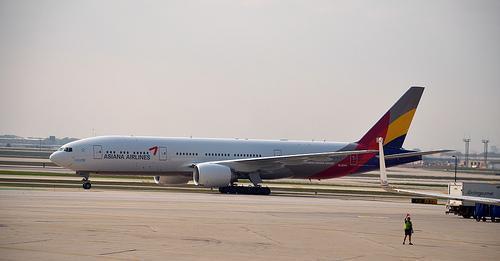How many engines are visible in this picture?
Give a very brief answer. 2. How many people are in this picture?
Give a very brief answer. 1. 